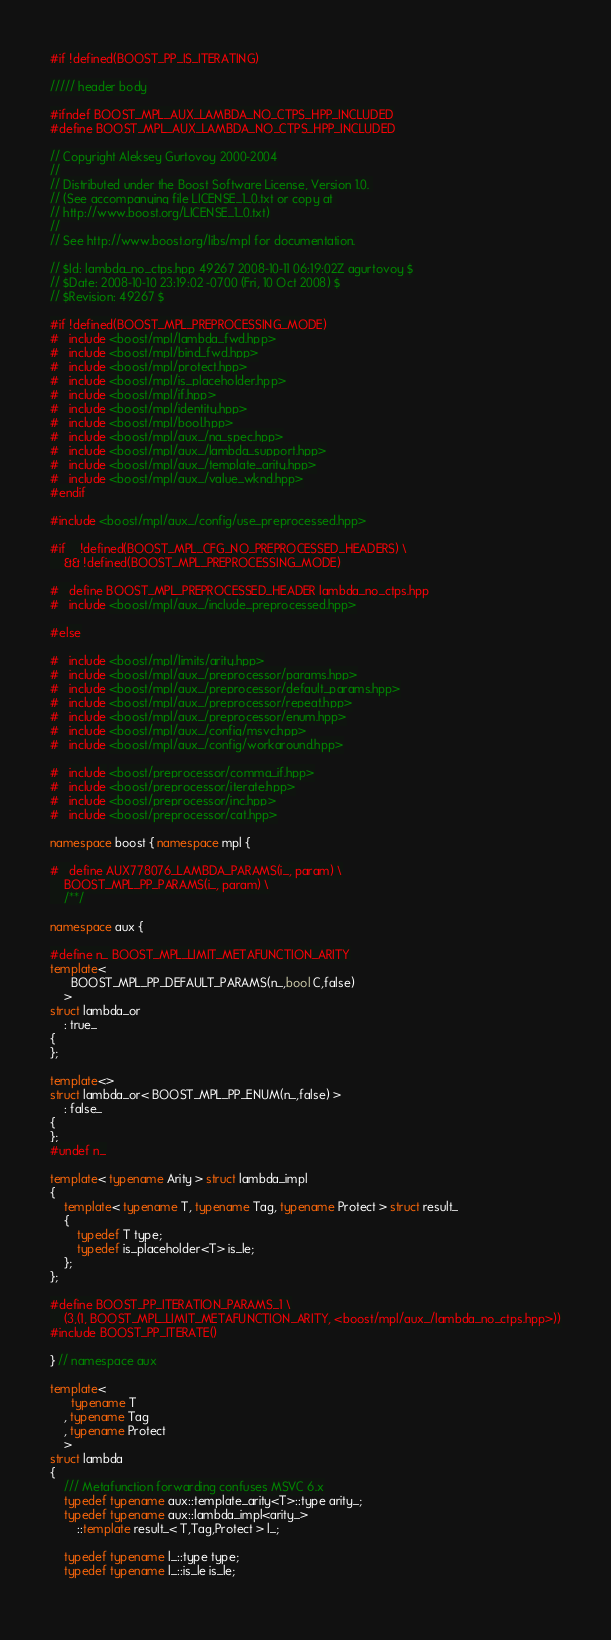<code> <loc_0><loc_0><loc_500><loc_500><_C++_>
#if !defined(BOOST_PP_IS_ITERATING)

///// header body

#ifndef BOOST_MPL_AUX_LAMBDA_NO_CTPS_HPP_INCLUDED
#define BOOST_MPL_AUX_LAMBDA_NO_CTPS_HPP_INCLUDED

// Copyright Aleksey Gurtovoy 2000-2004
//
// Distributed under the Boost Software License, Version 1.0. 
// (See accompanying file LICENSE_1_0.txt or copy at 
// http://www.boost.org/LICENSE_1_0.txt)
//
// See http://www.boost.org/libs/mpl for documentation.

// $Id: lambda_no_ctps.hpp 49267 2008-10-11 06:19:02Z agurtovoy $
// $Date: 2008-10-10 23:19:02 -0700 (Fri, 10 Oct 2008) $
// $Revision: 49267 $

#if !defined(BOOST_MPL_PREPROCESSING_MODE)
#   include <boost/mpl/lambda_fwd.hpp>
#   include <boost/mpl/bind_fwd.hpp>
#   include <boost/mpl/protect.hpp>
#   include <boost/mpl/is_placeholder.hpp>
#   include <boost/mpl/if.hpp>
#   include <boost/mpl/identity.hpp>
#   include <boost/mpl/bool.hpp>
#   include <boost/mpl/aux_/na_spec.hpp>
#   include <boost/mpl/aux_/lambda_support.hpp>
#   include <boost/mpl/aux_/template_arity.hpp>
#   include <boost/mpl/aux_/value_wknd.hpp>
#endif

#include <boost/mpl/aux_/config/use_preprocessed.hpp>

#if    !defined(BOOST_MPL_CFG_NO_PREPROCESSED_HEADERS) \
    && !defined(BOOST_MPL_PREPROCESSING_MODE)

#   define BOOST_MPL_PREPROCESSED_HEADER lambda_no_ctps.hpp
#   include <boost/mpl/aux_/include_preprocessed.hpp>

#else

#   include <boost/mpl/limits/arity.hpp>
#   include <boost/mpl/aux_/preprocessor/params.hpp>
#   include <boost/mpl/aux_/preprocessor/default_params.hpp>
#   include <boost/mpl/aux_/preprocessor/repeat.hpp>
#   include <boost/mpl/aux_/preprocessor/enum.hpp>
#   include <boost/mpl/aux_/config/msvc.hpp>
#   include <boost/mpl/aux_/config/workaround.hpp>

#   include <boost/preprocessor/comma_if.hpp>
#   include <boost/preprocessor/iterate.hpp>
#   include <boost/preprocessor/inc.hpp>
#   include <boost/preprocessor/cat.hpp>

namespace boost { namespace mpl {

#   define AUX778076_LAMBDA_PARAMS(i_, param) \
    BOOST_MPL_PP_PARAMS(i_, param) \
    /**/

namespace aux {

#define n_ BOOST_MPL_LIMIT_METAFUNCTION_ARITY
template<
      BOOST_MPL_PP_DEFAULT_PARAMS(n_,bool C,false)
    >
struct lambda_or
    : true_
{
};

template<>
struct lambda_or< BOOST_MPL_PP_ENUM(n_,false) >
    : false_
{
};
#undef n_

template< typename Arity > struct lambda_impl
{
    template< typename T, typename Tag, typename Protect > struct result_
    {
        typedef T type;
        typedef is_placeholder<T> is_le;
    };
};

#define BOOST_PP_ITERATION_PARAMS_1 \
    (3,(1, BOOST_MPL_LIMIT_METAFUNCTION_ARITY, <boost/mpl/aux_/lambda_no_ctps.hpp>))
#include BOOST_PP_ITERATE()

} // namespace aux

template<
      typename T
    , typename Tag
    , typename Protect
    >
struct lambda
{
    /// Metafunction forwarding confuses MSVC 6.x
    typedef typename aux::template_arity<T>::type arity_;
    typedef typename aux::lambda_impl<arity_>
        ::template result_< T,Tag,Protect > l_;

    typedef typename l_::type type;
    typedef typename l_::is_le is_le;
    </code> 